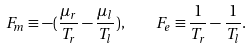Convert formula to latex. <formula><loc_0><loc_0><loc_500><loc_500>F _ { m } \equiv - ( \frac { \mu _ { r } } { T _ { r } } - \frac { \mu _ { l } } { T _ { l } } ) , \quad F _ { e } \equiv \frac { 1 } { T _ { r } } - \frac { 1 } { T _ { l } } .</formula> 